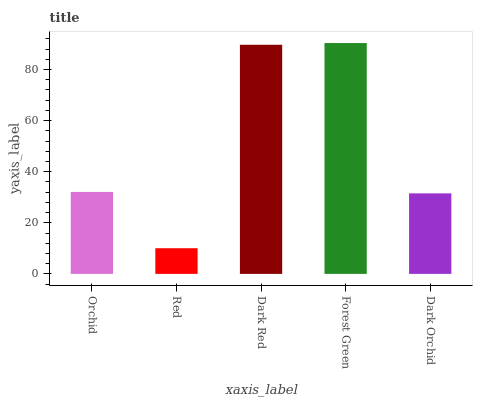Is Red the minimum?
Answer yes or no. Yes. Is Forest Green the maximum?
Answer yes or no. Yes. Is Dark Red the minimum?
Answer yes or no. No. Is Dark Red the maximum?
Answer yes or no. No. Is Dark Red greater than Red?
Answer yes or no. Yes. Is Red less than Dark Red?
Answer yes or no. Yes. Is Red greater than Dark Red?
Answer yes or no. No. Is Dark Red less than Red?
Answer yes or no. No. Is Orchid the high median?
Answer yes or no. Yes. Is Orchid the low median?
Answer yes or no. Yes. Is Forest Green the high median?
Answer yes or no. No. Is Dark Red the low median?
Answer yes or no. No. 